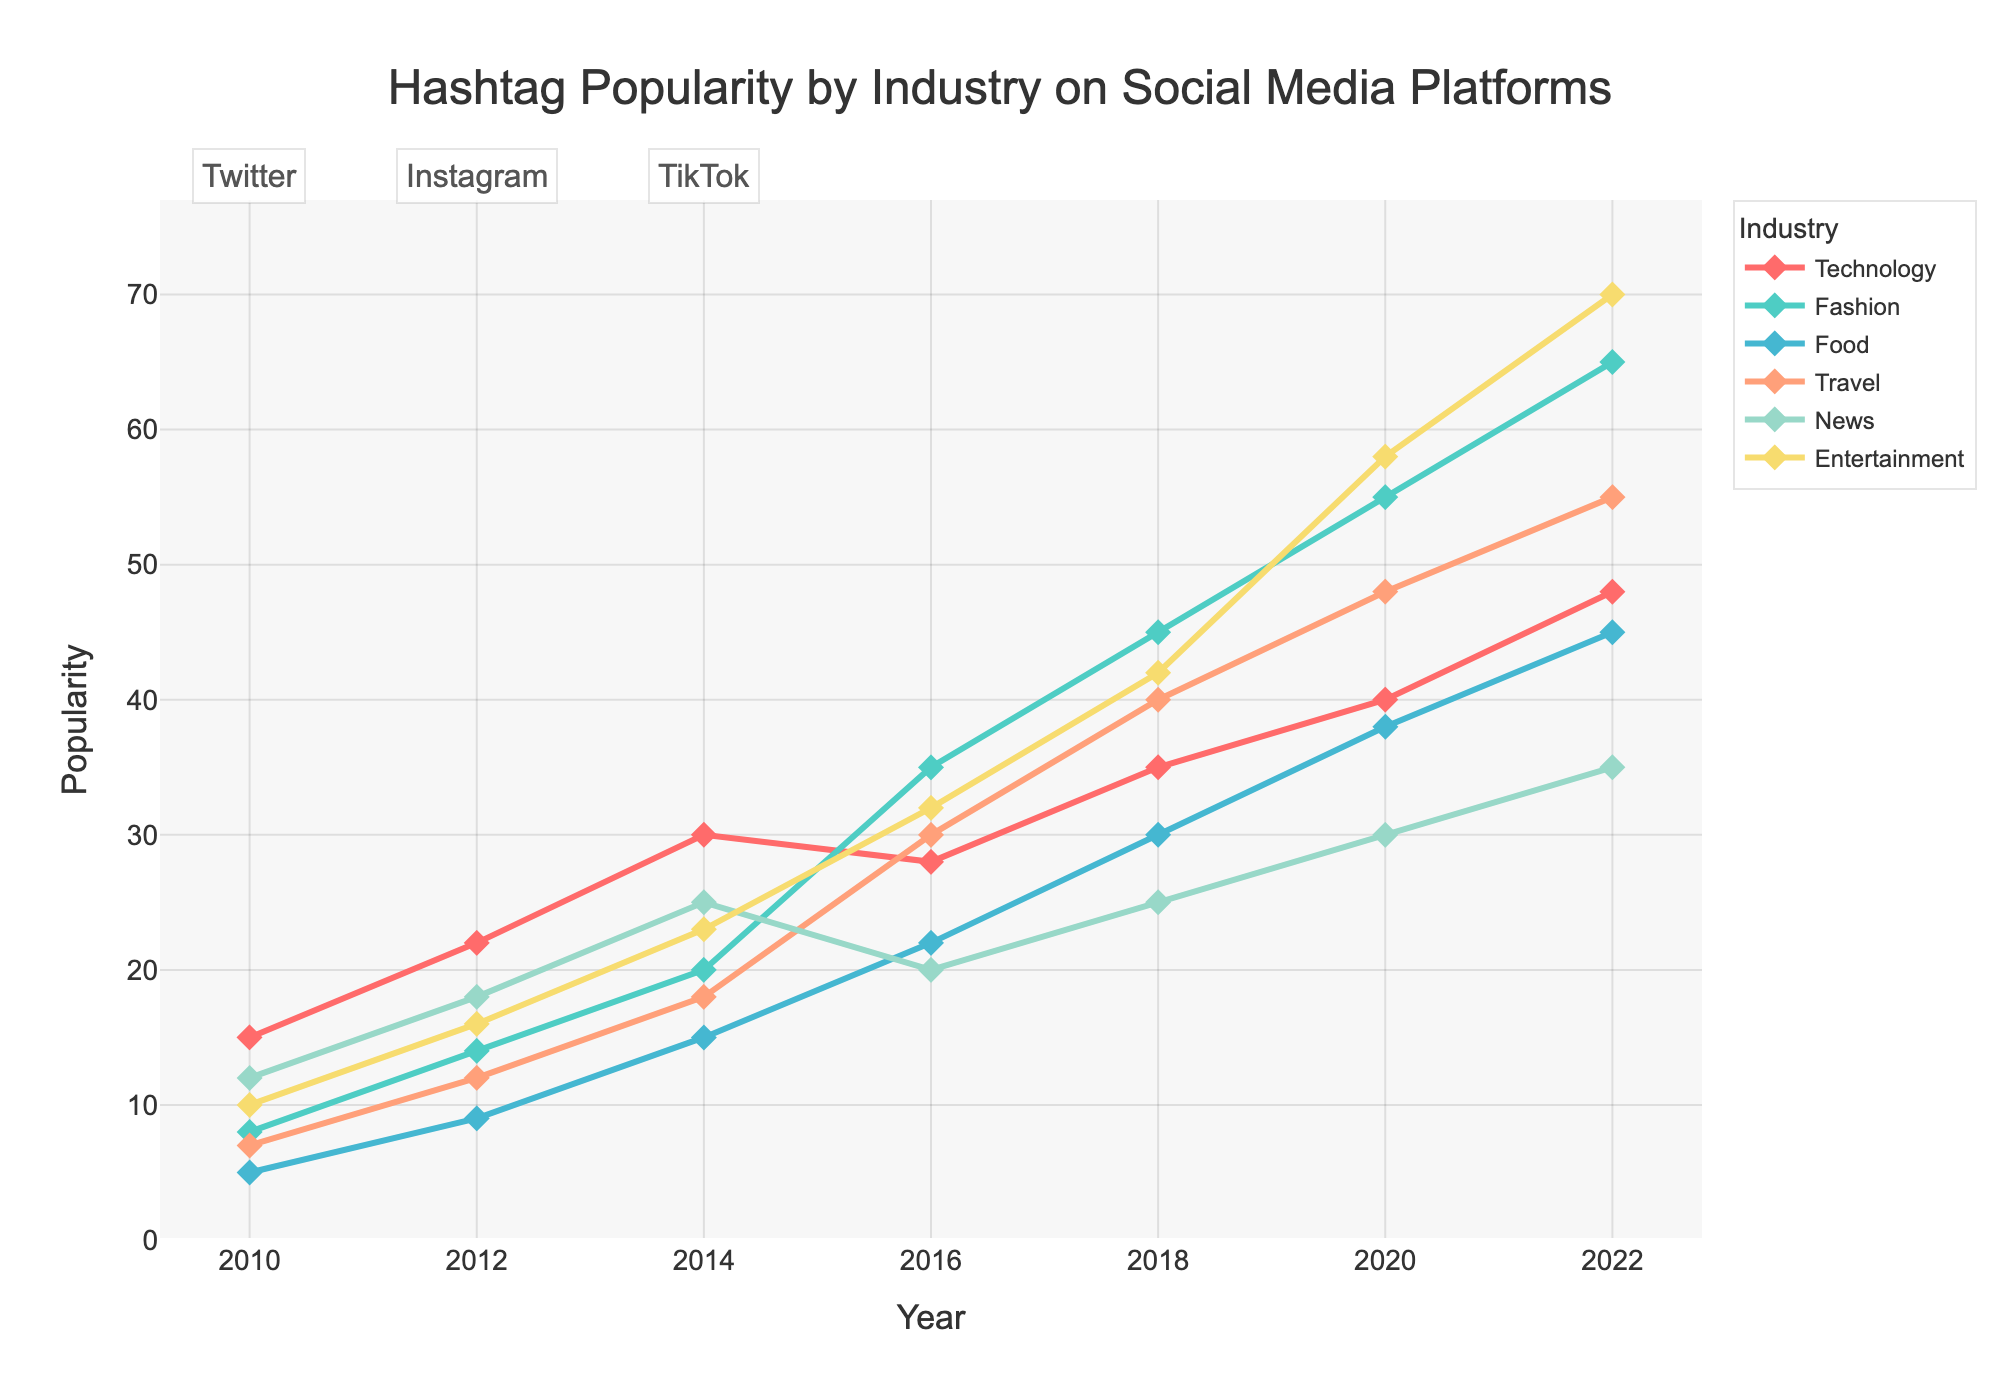Which industry showed the highest increase in popularity on TikTok from 2020 to 2022? From the figure, look at the segments of the line chart for TikTok (years 2020 and 2022). Compare the differences in the Y-values (popularity) for each industry between these two years. The Entertainment industry increased from 58 to 70, which is the highest increase.
Answer: Entertainment Which year did the Fashion industry surpass the Technology industry in popularity? Look for the year when the line representing the Fashion industry rises above the line representing the Technology industry. Fashion surpasses Technology in 2016.
Answer: 2016 Between 2014 and 2016, which industry saw the largest drop in popularity on Twitter? Compare the year 2014 with 2016. For these years, look at the popularity values for Technology, Fashion, Food, Travel, News, and Entertainment on Twitter. Since Twitter's data stops at 2014, none saw a drop as the comparison doesn't exist for 2016.
Answer: None What was the average popularity of hashtags in the Food industry across all years displayed? To get the average, add the popularity values for the Food industry across all years (5+9+15+22+30+38+45), then divide by 7 (years). The sum is 164, and the average is 164/7.
Answer: 23.43 Which social media platform hosts the highest diversification of industry popularity in 2022? Review 2022, look for the highest spread of popularity values among industries. TikTok shows a wide range of values in 2022 (Technology: 48, Fashion: 65, Food: 45, Travel: 55, News: 35, Entertainment: 70).
Answer: TikTok What is the correlation between the popularity of hashtags in the Technology and Entertainment industries from 2010 to 2022? Examine the trends of the Technology and Entertainment lines. Both show an overall increasing pattern, indicating a positive correlation. Compute the correlation by comparing the trends visually across all years.
Answer: Positive In which year did the Travel industry gain the most popularity in absolute terms? Compare the increases in Travel industry popularity from one year to the next. The largest absolute increase occurs from 2016 to 2018 (30 to 40, an increase of 10).
Answer: 2018 